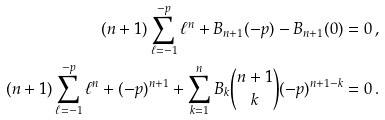Convert formula to latex. <formula><loc_0><loc_0><loc_500><loc_500>( n + 1 ) \sum _ { \ell = - 1 } ^ { - p } \ell ^ { n } + B _ { n + 1 } ( - p ) - B _ { n + 1 } ( 0 ) = 0 \, , \\ ( n + 1 ) \sum _ { \ell = - 1 } ^ { - p } \ell ^ { n } + ( - p ) ^ { n + 1 } + \sum _ { k = 1 } ^ { n } B _ { k } \binom { n + 1 } { k } ( - p ) ^ { n + 1 - k } = 0 \, .</formula> 